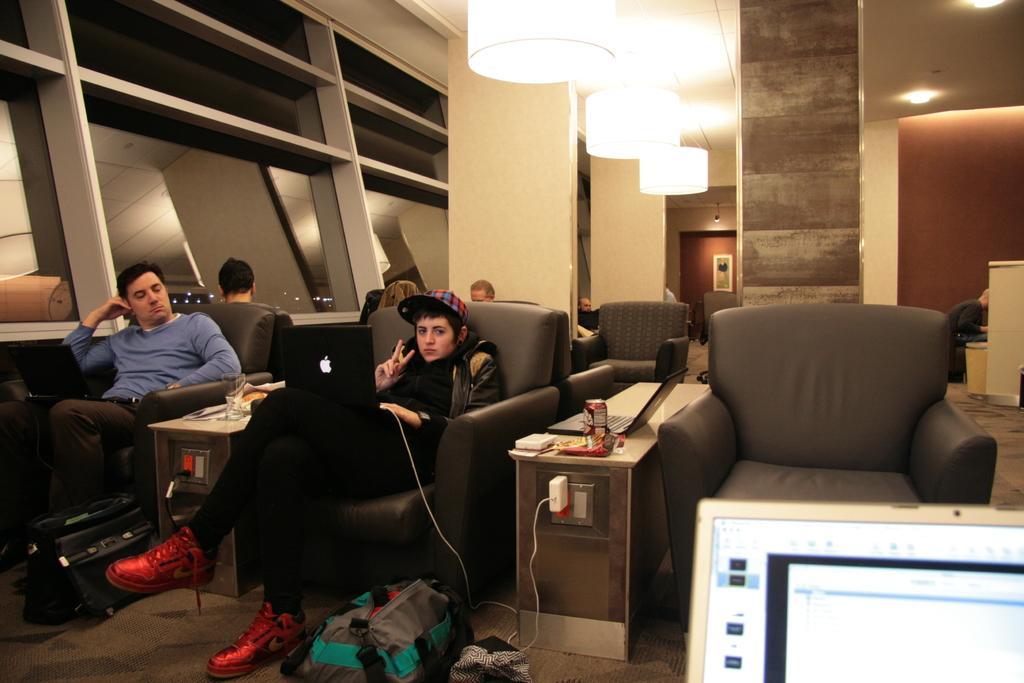Describe this image in one or two sentences. In the image we can see few persons were sitting on sofa. In center we can see woman she is holding laptop. And in between them we can see table on table we can see few objects. On the right corner we can see the tab. The bottom center we can see back packs and coming to back there is a light, pillar,wall,door etc. 